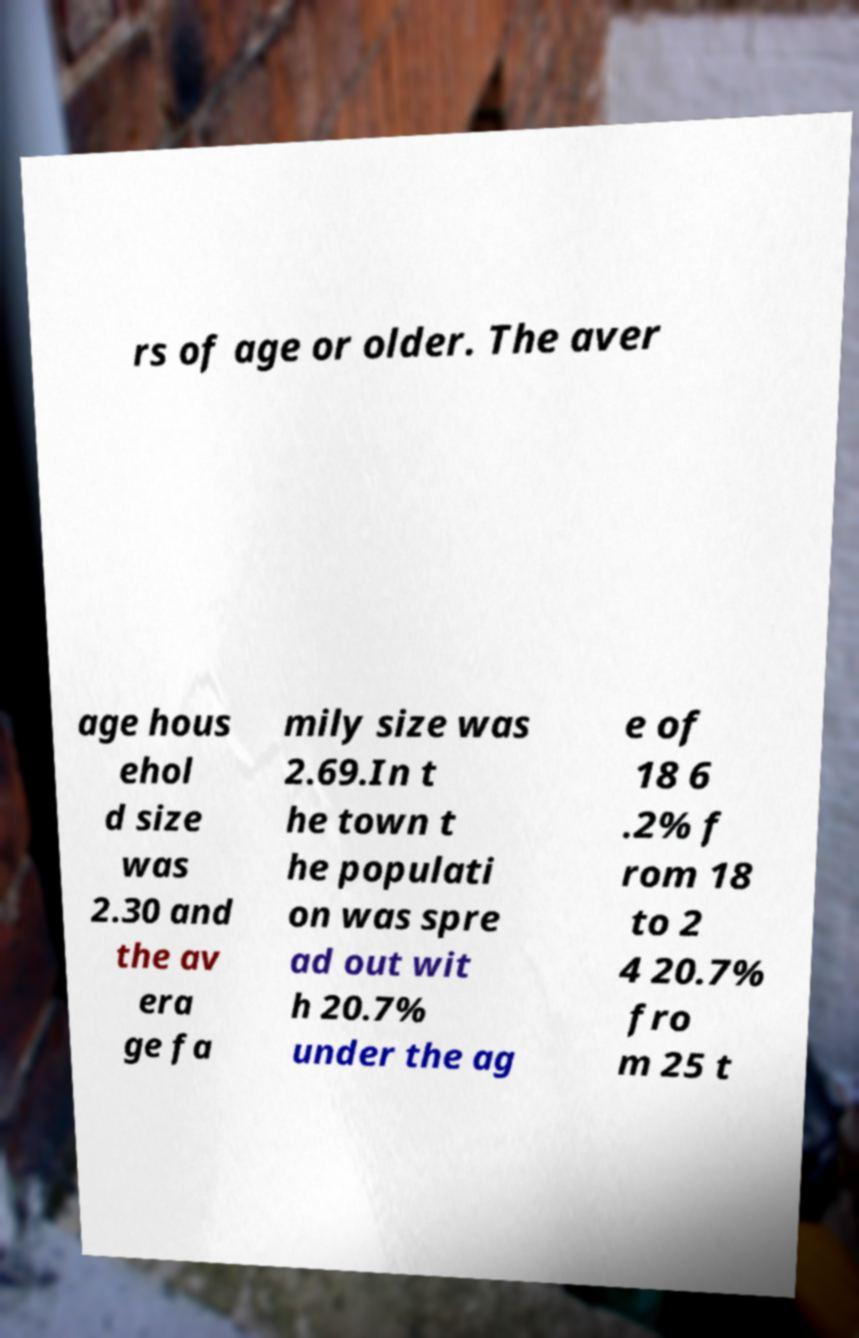What messages or text are displayed in this image? I need them in a readable, typed format. rs of age or older. The aver age hous ehol d size was 2.30 and the av era ge fa mily size was 2.69.In t he town t he populati on was spre ad out wit h 20.7% under the ag e of 18 6 .2% f rom 18 to 2 4 20.7% fro m 25 t 